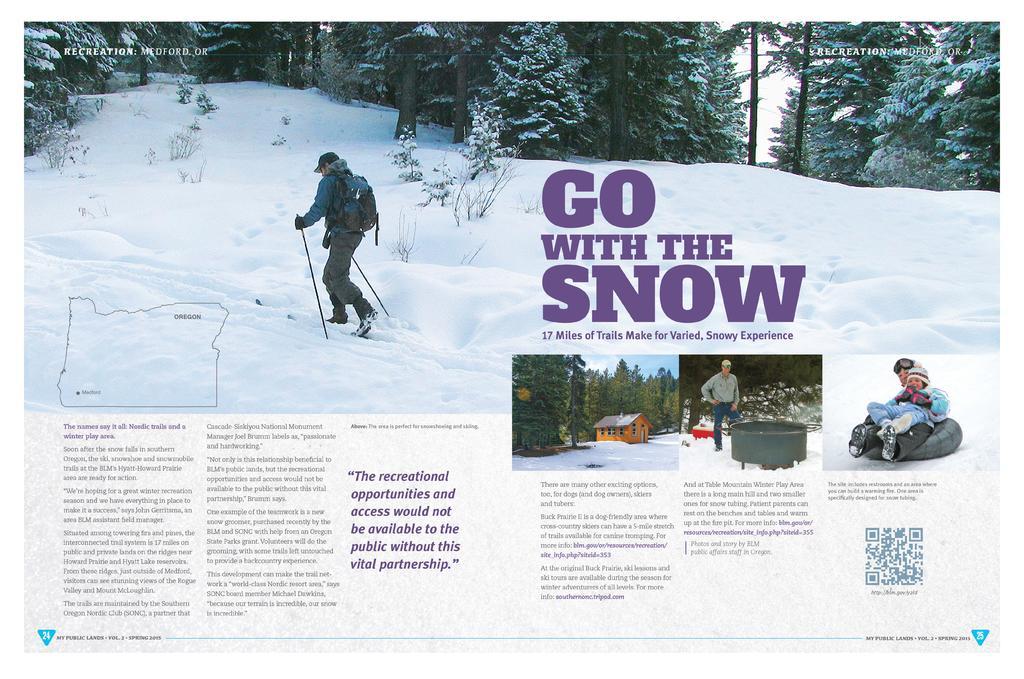Can you describe this image briefly? It is an edited image, there is a person trekking on the snow and below that picture there is an article related to the snow. 